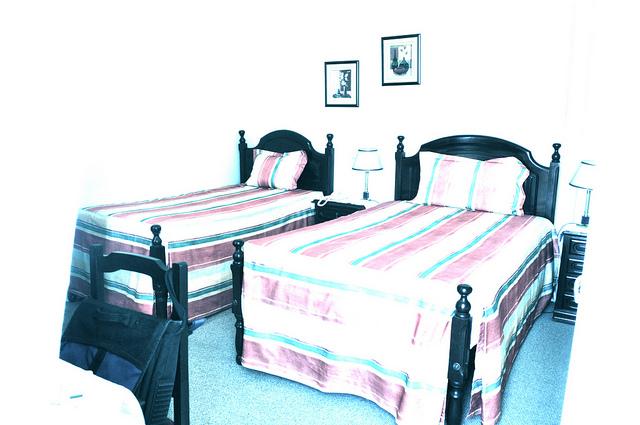What size beds are these?
Quick response, please. Twin. Are these beds made?
Give a very brief answer. Yes. How many beds are there?
Keep it brief. 2. 